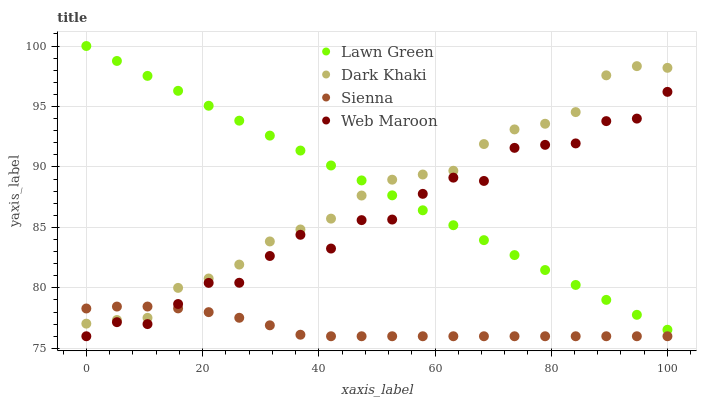Does Sienna have the minimum area under the curve?
Answer yes or no. Yes. Does Lawn Green have the maximum area under the curve?
Answer yes or no. Yes. Does Web Maroon have the minimum area under the curve?
Answer yes or no. No. Does Web Maroon have the maximum area under the curve?
Answer yes or no. No. Is Lawn Green the smoothest?
Answer yes or no. Yes. Is Web Maroon the roughest?
Answer yes or no. Yes. Is Web Maroon the smoothest?
Answer yes or no. No. Is Lawn Green the roughest?
Answer yes or no. No. Does Web Maroon have the lowest value?
Answer yes or no. Yes. Does Lawn Green have the lowest value?
Answer yes or no. No. Does Lawn Green have the highest value?
Answer yes or no. Yes. Does Web Maroon have the highest value?
Answer yes or no. No. Is Web Maroon less than Dark Khaki?
Answer yes or no. Yes. Is Dark Khaki greater than Web Maroon?
Answer yes or no. Yes. Does Dark Khaki intersect Lawn Green?
Answer yes or no. Yes. Is Dark Khaki less than Lawn Green?
Answer yes or no. No. Is Dark Khaki greater than Lawn Green?
Answer yes or no. No. Does Web Maroon intersect Dark Khaki?
Answer yes or no. No. 